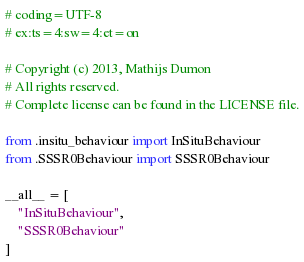Convert code to text. <code><loc_0><loc_0><loc_500><loc_500><_Python_># coding=UTF-8
# ex:ts=4:sw=4:et=on

# Copyright (c) 2013, Mathijs Dumon
# All rights reserved.
# Complete license can be found in the LICENSE file.

from .insitu_behaviour import InSituBehaviour
from .SSSR0Behaviour import SSSR0Behaviour

__all__ = [
    "InSituBehaviour",
    "SSSR0Behaviour"
]
</code> 